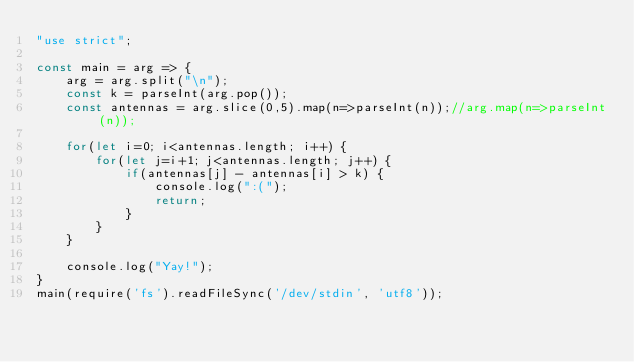Convert code to text. <code><loc_0><loc_0><loc_500><loc_500><_JavaScript_>"use strict";
    
const main = arg => {
    arg = arg.split("\n");
    const k = parseInt(arg.pop());
    const antennas = arg.slice(0,5).map(n=>parseInt(n));//arg.map(n=>parseInt(n));
    
    for(let i=0; i<antennas.length; i++) {
        for(let j=i+1; j<antennas.length; j++) {
            if(antennas[j] - antennas[i] > k) {
                console.log(":(");
                return;
            }   
        }
    }
    
    console.log("Yay!");
}
main(require('fs').readFileSync('/dev/stdin', 'utf8'));
</code> 